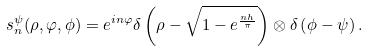<formula> <loc_0><loc_0><loc_500><loc_500>s _ { n } ^ { \psi } ( \rho , \varphi , \phi ) = e ^ { i n \varphi } \delta \left ( \rho - \sqrt { 1 - e ^ { \frac { n h } { \pi } } } \right ) \otimes \delta \left ( \phi - \psi \right ) .</formula> 